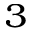<formula> <loc_0><loc_0><loc_500><loc_500>^ { 3 }</formula> 